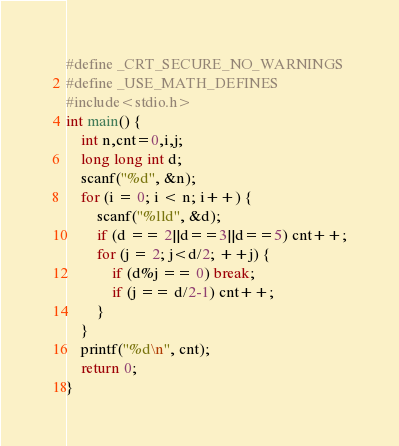Convert code to text. <code><loc_0><loc_0><loc_500><loc_500><_C_>#define _CRT_SECURE_NO_WARNINGS
#define _USE_MATH_DEFINES
#include<stdio.h>
int main() {
	int n,cnt=0,i,j;
	long long int d;
	scanf("%d", &n);
	for (i = 0; i < n; i++) {
		scanf("%lld", &d);
		if (d == 2||d==3||d==5) cnt++;
		for (j = 2; j<d/2; ++j) {
			if (d%j == 0) break;
			if (j == d/2-1) cnt++;
		}
	}
	printf("%d\n", cnt);
	return 0;
}</code> 